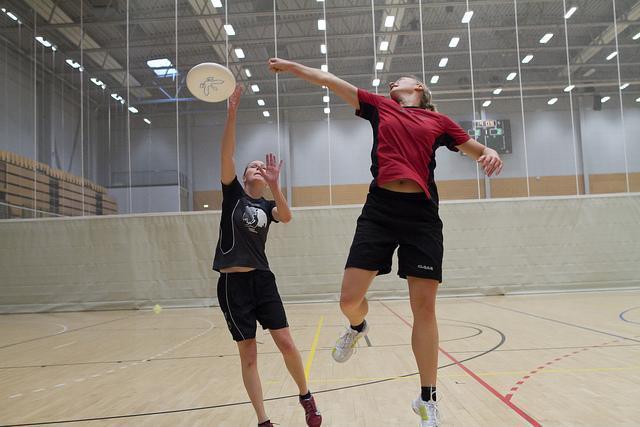How many people are in the picture?
Give a very brief answer. 2. 